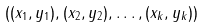<formula> <loc_0><loc_0><loc_500><loc_500>( ( x _ { 1 } , y _ { 1 } ) , ( x _ { 2 } , y _ { 2 } ) , \dots , ( x _ { k } , y _ { k } ) )</formula> 